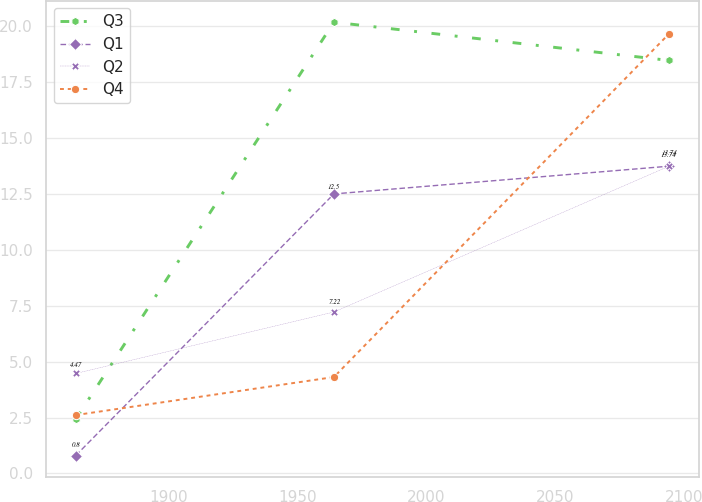<chart> <loc_0><loc_0><loc_500><loc_500><line_chart><ecel><fcel>Q3<fcel>Q1<fcel>Q2<fcel>Q4<nl><fcel>1864.08<fcel>2.43<fcel>0.8<fcel>4.47<fcel>2.61<nl><fcel>1964.23<fcel>20.18<fcel>12.5<fcel>7.22<fcel>4.31<nl><fcel>2094.21<fcel>18.47<fcel>13.74<fcel>13.74<fcel>19.66<nl></chart> 